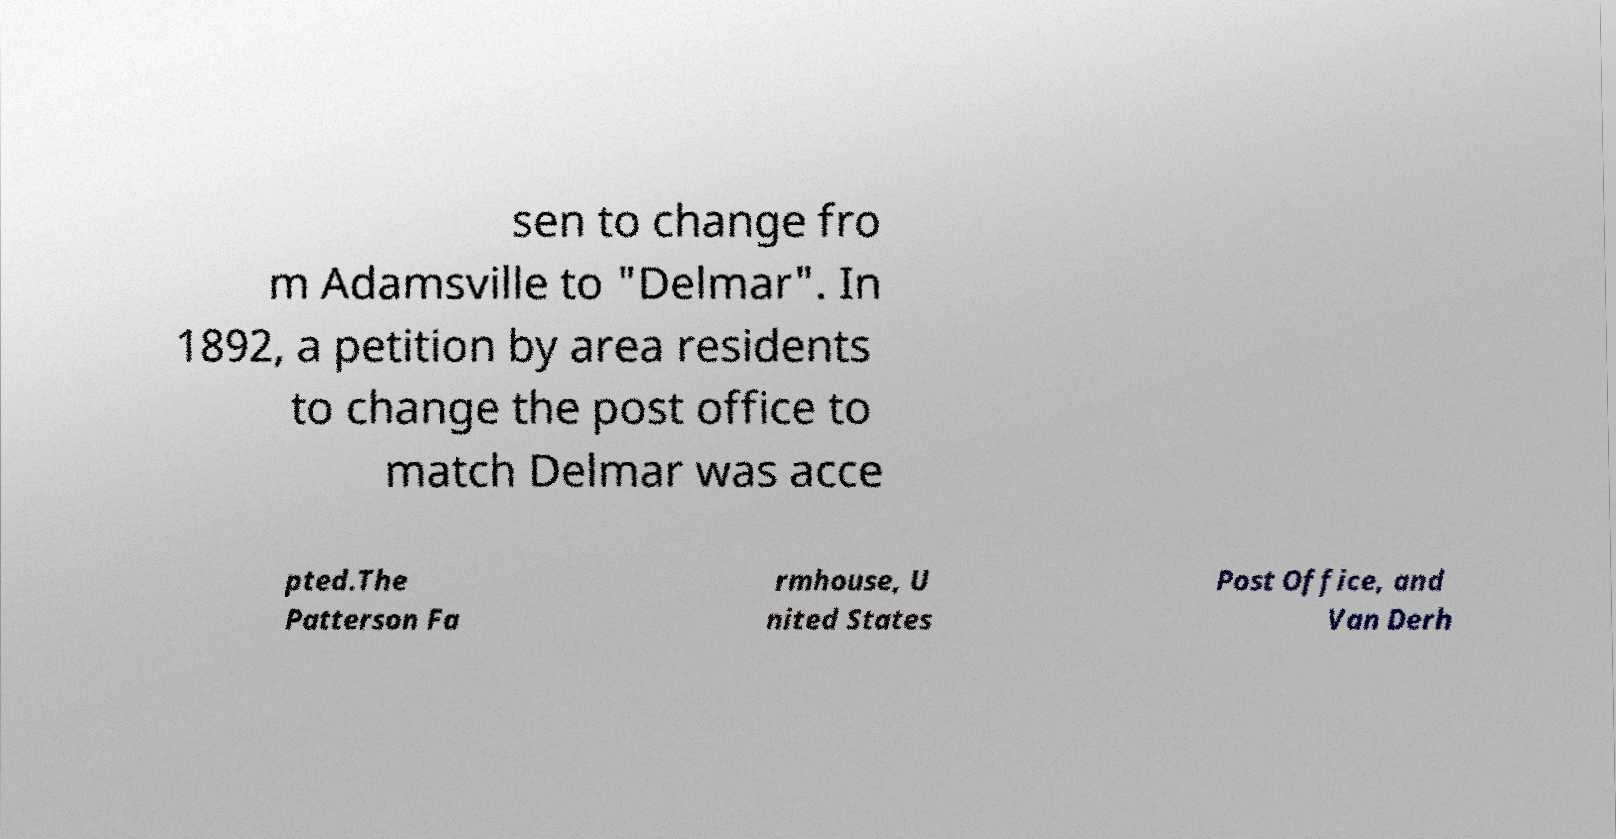Please identify and transcribe the text found in this image. sen to change fro m Adamsville to "Delmar". In 1892, a petition by area residents to change the post office to match Delmar was acce pted.The Patterson Fa rmhouse, U nited States Post Office, and Van Derh 